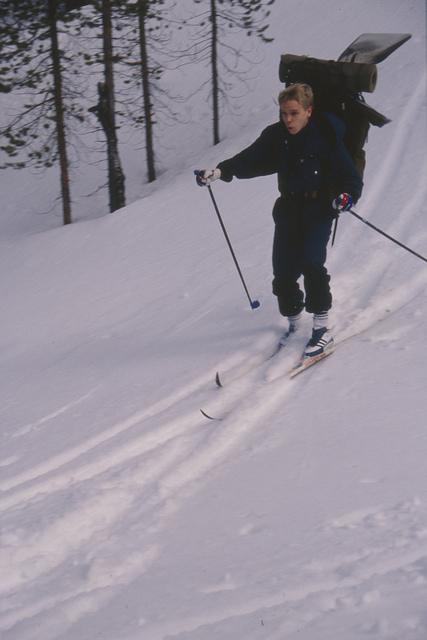What is the shovel carried here meant to be used for first? snow removal 